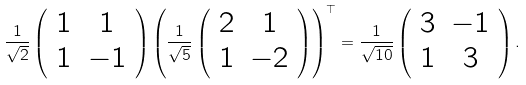Convert formula to latex. <formula><loc_0><loc_0><loc_500><loc_500>\frac { 1 } { \sqrt { 2 } } \left ( \begin{array} { c c } 1 & 1 \\ 1 & - 1 \end{array} \right ) \left ( \frac { 1 } { \sqrt { 5 } } \left ( \begin{array} { c c } 2 & 1 \\ 1 & - 2 \end{array} \right ) \right ) ^ { \top } = \frac { 1 } { \sqrt { 1 0 } } \left ( \begin{array} { c c } 3 & - 1 \\ 1 & 3 \end{array} \right ) .</formula> 